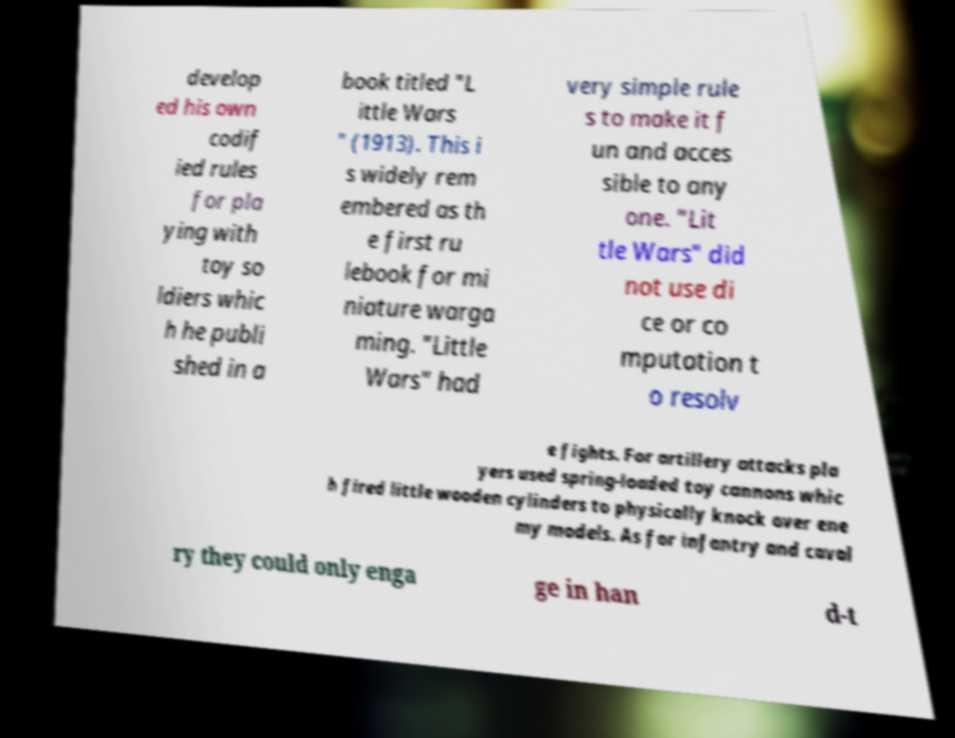Can you read and provide the text displayed in the image?This photo seems to have some interesting text. Can you extract and type it out for me? develop ed his own codif ied rules for pla ying with toy so ldiers whic h he publi shed in a book titled "L ittle Wars " (1913). This i s widely rem embered as th e first ru lebook for mi niature warga ming. "Little Wars" had very simple rule s to make it f un and acces sible to any one. "Lit tle Wars" did not use di ce or co mputation t o resolv e fights. For artillery attacks pla yers used spring-loaded toy cannons whic h fired little wooden cylinders to physically knock over ene my models. As for infantry and caval ry they could only enga ge in han d-t 